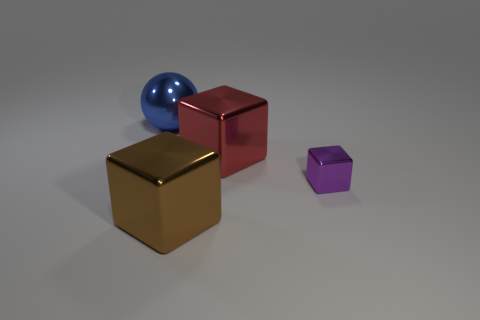Subtract all brown cubes. How many cubes are left? 2 Add 2 brown blocks. How many objects exist? 6 Subtract 0 purple cylinders. How many objects are left? 4 Subtract all cubes. How many objects are left? 1 Subtract all blue blocks. Subtract all red balls. How many blocks are left? 3 Subtract all cubes. Subtract all large brown blocks. How many objects are left? 0 Add 4 red blocks. How many red blocks are left? 5 Add 4 tiny purple blocks. How many tiny purple blocks exist? 5 